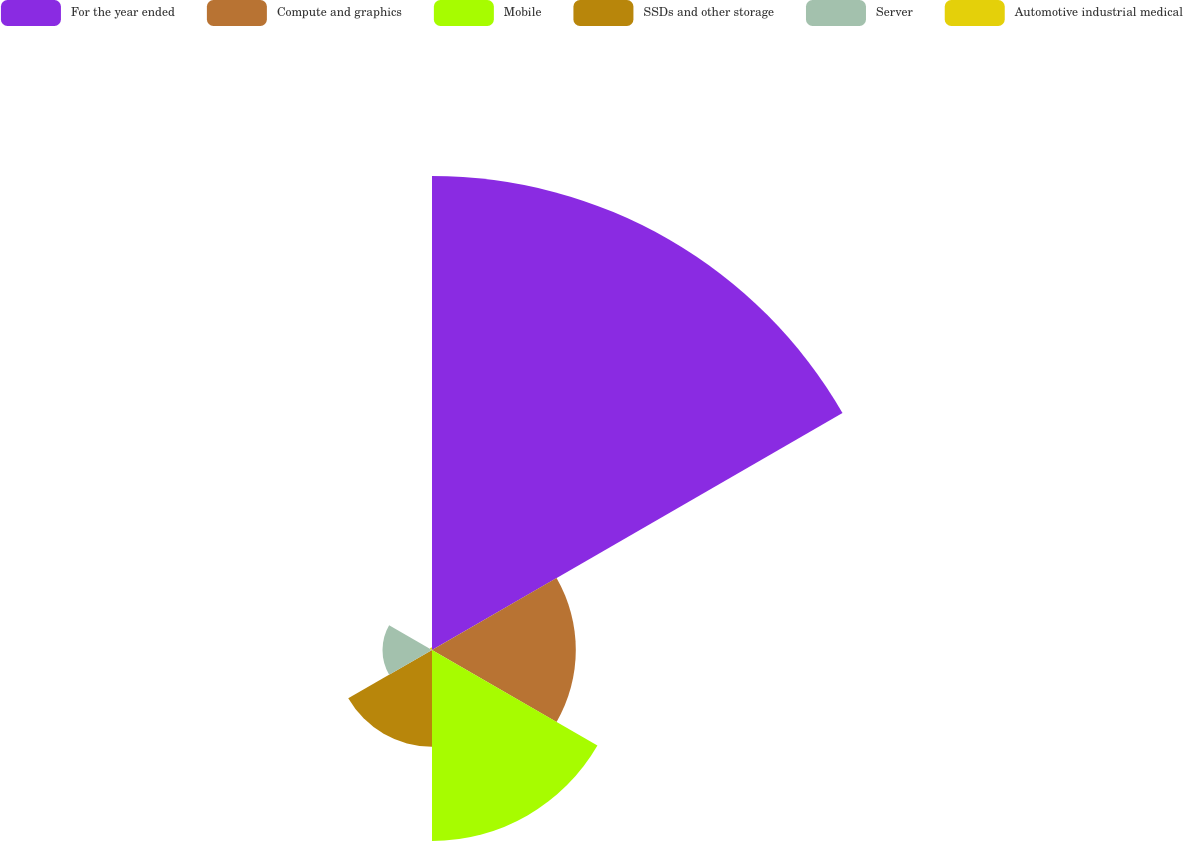Convert chart to OTSL. <chart><loc_0><loc_0><loc_500><loc_500><pie_chart><fcel>For the year ended<fcel>Compute and graphics<fcel>Mobile<fcel>SSDs and other storage<fcel>Server<fcel>Automotive industrial medical<nl><fcel>49.51%<fcel>15.02%<fcel>19.95%<fcel>10.1%<fcel>5.17%<fcel>0.25%<nl></chart> 